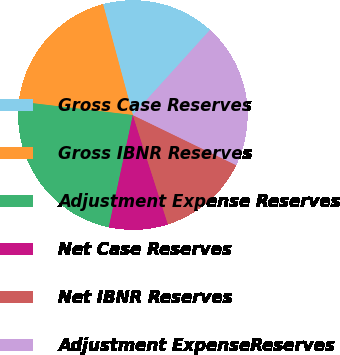Convert chart to OTSL. <chart><loc_0><loc_0><loc_500><loc_500><pie_chart><fcel>Gross Case Reserves<fcel>Gross IBNR Reserves<fcel>Adjustment Expense Reserves<fcel>Net Case Reserves<fcel>Net IBNR Reserves<fcel>Adjustment ExpenseReserves<nl><fcel>15.91%<fcel>18.95%<fcel>23.51%<fcel>8.31%<fcel>12.87%<fcel>20.47%<nl></chart> 